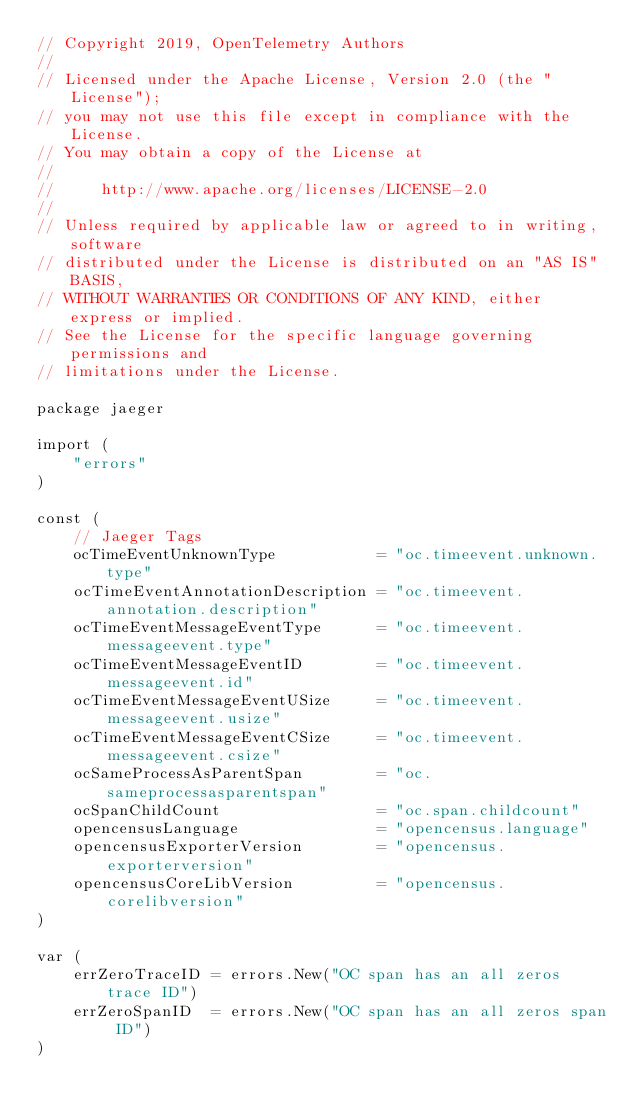<code> <loc_0><loc_0><loc_500><loc_500><_Go_>// Copyright 2019, OpenTelemetry Authors
//
// Licensed under the Apache License, Version 2.0 (the "License");
// you may not use this file except in compliance with the License.
// You may obtain a copy of the License at
//
//     http://www.apache.org/licenses/LICENSE-2.0
//
// Unless required by applicable law or agreed to in writing, software
// distributed under the License is distributed on an "AS IS" BASIS,
// WITHOUT WARRANTIES OR CONDITIONS OF ANY KIND, either express or implied.
// See the License for the specific language governing permissions and
// limitations under the License.

package jaeger

import (
	"errors"
)

const (
	// Jaeger Tags
	ocTimeEventUnknownType           = "oc.timeevent.unknown.type"
	ocTimeEventAnnotationDescription = "oc.timeevent.annotation.description"
	ocTimeEventMessageEventType      = "oc.timeevent.messageevent.type"
	ocTimeEventMessageEventID        = "oc.timeevent.messageevent.id"
	ocTimeEventMessageEventUSize     = "oc.timeevent.messageevent.usize"
	ocTimeEventMessageEventCSize     = "oc.timeevent.messageevent.csize"
	ocSameProcessAsParentSpan        = "oc.sameprocessasparentspan"
	ocSpanChildCount                 = "oc.span.childcount"
	opencensusLanguage               = "opencensus.language"
	opencensusExporterVersion        = "opencensus.exporterversion"
	opencensusCoreLibVersion         = "opencensus.corelibversion"
)

var (
	errZeroTraceID = errors.New("OC span has an all zeros trace ID")
	errZeroSpanID  = errors.New("OC span has an all zeros span ID")
)
</code> 